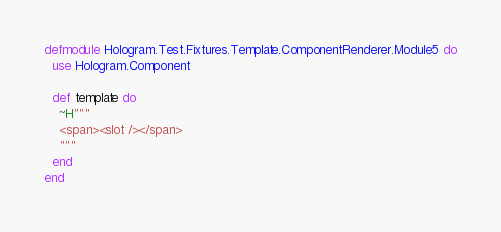<code> <loc_0><loc_0><loc_500><loc_500><_Elixir_>defmodule Hologram.Test.Fixtures.Template.ComponentRenderer.Module5 do
  use Hologram.Component

  def template do
    ~H"""
    <span><slot /></span>
    """
  end
end
</code> 